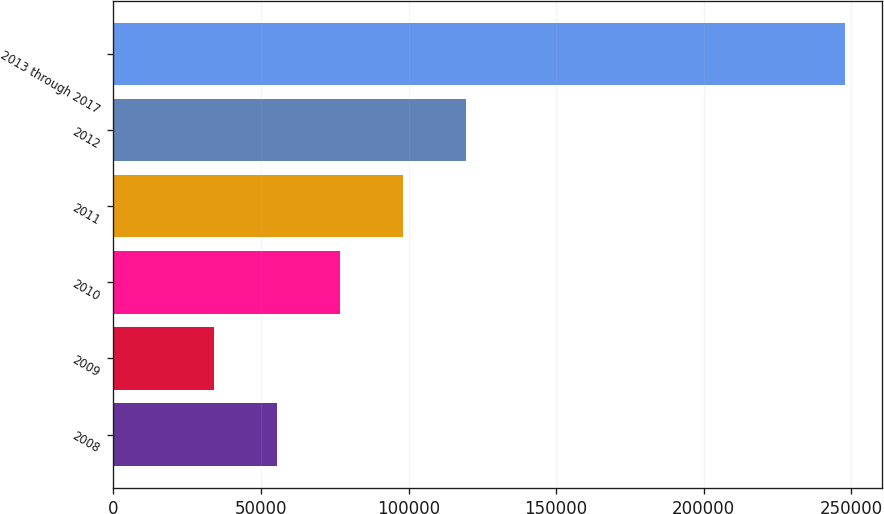<chart> <loc_0><loc_0><loc_500><loc_500><bar_chart><fcel>2008<fcel>2009<fcel>2010<fcel>2011<fcel>2012<fcel>2013 through 2017<nl><fcel>55437.4<fcel>34038<fcel>76836.8<fcel>98236.2<fcel>119636<fcel>248032<nl></chart> 